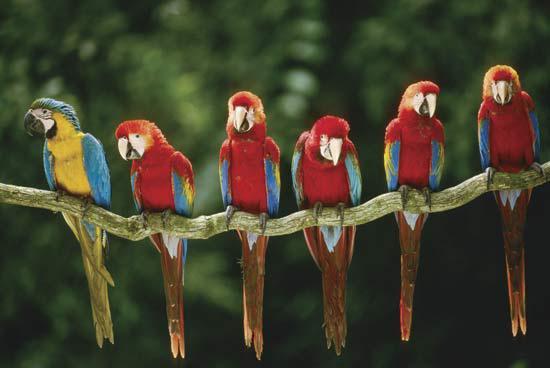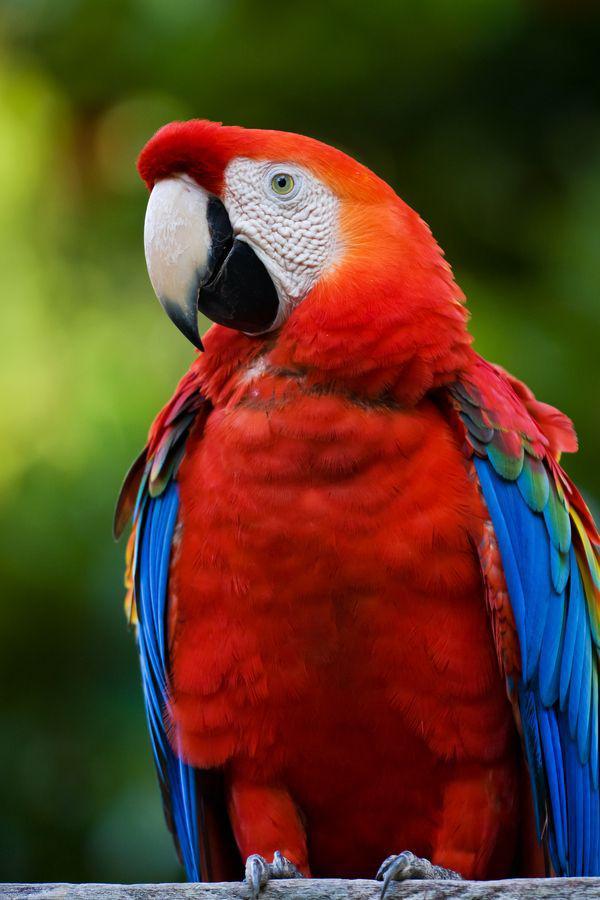The first image is the image on the left, the second image is the image on the right. For the images displayed, is the sentence "A total of three parrots are depicted in the images." factually correct? Answer yes or no. No. The first image is the image on the left, the second image is the image on the right. Analyze the images presented: Is the assertion "In one image, two teal colored parrots are sitting together on a tree branch." valid? Answer yes or no. No. 